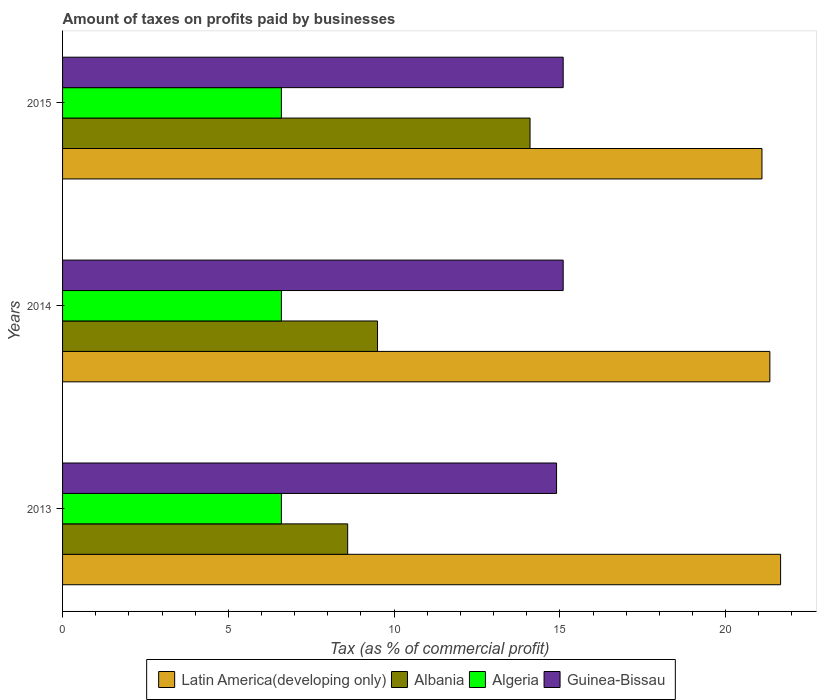How many groups of bars are there?
Offer a very short reply. 3. Are the number of bars per tick equal to the number of legend labels?
Keep it short and to the point. Yes. Are the number of bars on each tick of the Y-axis equal?
Provide a succinct answer. Yes. How many bars are there on the 3rd tick from the bottom?
Provide a succinct answer. 4. What is the label of the 1st group of bars from the top?
Ensure brevity in your answer.  2015. In how many cases, is the number of bars for a given year not equal to the number of legend labels?
Make the answer very short. 0. What is the percentage of taxes paid by businesses in Guinea-Bissau in 2015?
Make the answer very short. 15.1. In which year was the percentage of taxes paid by businesses in Albania maximum?
Your response must be concise. 2015. In which year was the percentage of taxes paid by businesses in Latin America(developing only) minimum?
Offer a terse response. 2015. What is the total percentage of taxes paid by businesses in Latin America(developing only) in the graph?
Provide a succinct answer. 64.09. What is the difference between the percentage of taxes paid by businesses in Algeria in 2014 and the percentage of taxes paid by businesses in Latin America(developing only) in 2015?
Make the answer very short. -14.5. What is the average percentage of taxes paid by businesses in Algeria per year?
Offer a terse response. 6.6. In the year 2014, what is the difference between the percentage of taxes paid by businesses in Latin America(developing only) and percentage of taxes paid by businesses in Albania?
Offer a terse response. 11.83. In how many years, is the percentage of taxes paid by businesses in Algeria greater than 21 %?
Provide a short and direct response. 0. What is the ratio of the percentage of taxes paid by businesses in Algeria in 2013 to that in 2015?
Give a very brief answer. 1. Is the percentage of taxes paid by businesses in Albania in 2013 less than that in 2015?
Your response must be concise. Yes. Is the difference between the percentage of taxes paid by businesses in Latin America(developing only) in 2013 and 2015 greater than the difference between the percentage of taxes paid by businesses in Albania in 2013 and 2015?
Offer a terse response. Yes. What is the difference between the highest and the second highest percentage of taxes paid by businesses in Latin America(developing only)?
Keep it short and to the point. 0.32. What is the difference between the highest and the lowest percentage of taxes paid by businesses in Albania?
Make the answer very short. 5.5. Is it the case that in every year, the sum of the percentage of taxes paid by businesses in Guinea-Bissau and percentage of taxes paid by businesses in Algeria is greater than the sum of percentage of taxes paid by businesses in Albania and percentage of taxes paid by businesses in Latin America(developing only)?
Offer a very short reply. No. What does the 1st bar from the top in 2015 represents?
Offer a terse response. Guinea-Bissau. What does the 1st bar from the bottom in 2015 represents?
Your response must be concise. Latin America(developing only). Are all the bars in the graph horizontal?
Keep it short and to the point. Yes. Does the graph contain any zero values?
Your answer should be very brief. No. Where does the legend appear in the graph?
Your answer should be very brief. Bottom center. How many legend labels are there?
Give a very brief answer. 4. What is the title of the graph?
Your response must be concise. Amount of taxes on profits paid by businesses. What is the label or title of the X-axis?
Provide a short and direct response. Tax (as % of commercial profit). What is the Tax (as % of commercial profit) in Latin America(developing only) in 2013?
Your answer should be compact. 21.66. What is the Tax (as % of commercial profit) of Algeria in 2013?
Provide a short and direct response. 6.6. What is the Tax (as % of commercial profit) in Guinea-Bissau in 2013?
Provide a short and direct response. 14.9. What is the Tax (as % of commercial profit) of Latin America(developing only) in 2014?
Keep it short and to the point. 21.33. What is the Tax (as % of commercial profit) in Albania in 2014?
Your answer should be compact. 9.5. What is the Tax (as % of commercial profit) of Algeria in 2014?
Keep it short and to the point. 6.6. What is the Tax (as % of commercial profit) of Latin America(developing only) in 2015?
Your answer should be compact. 21.1. Across all years, what is the maximum Tax (as % of commercial profit) of Latin America(developing only)?
Provide a succinct answer. 21.66. Across all years, what is the maximum Tax (as % of commercial profit) in Albania?
Give a very brief answer. 14.1. Across all years, what is the maximum Tax (as % of commercial profit) in Guinea-Bissau?
Make the answer very short. 15.1. Across all years, what is the minimum Tax (as % of commercial profit) of Latin America(developing only)?
Give a very brief answer. 21.1. Across all years, what is the minimum Tax (as % of commercial profit) of Algeria?
Your answer should be compact. 6.6. Across all years, what is the minimum Tax (as % of commercial profit) in Guinea-Bissau?
Offer a very short reply. 14.9. What is the total Tax (as % of commercial profit) in Latin America(developing only) in the graph?
Your answer should be very brief. 64.09. What is the total Tax (as % of commercial profit) in Albania in the graph?
Ensure brevity in your answer.  32.2. What is the total Tax (as % of commercial profit) of Algeria in the graph?
Make the answer very short. 19.8. What is the total Tax (as % of commercial profit) in Guinea-Bissau in the graph?
Give a very brief answer. 45.1. What is the difference between the Tax (as % of commercial profit) in Latin America(developing only) in 2013 and that in 2014?
Your answer should be very brief. 0.32. What is the difference between the Tax (as % of commercial profit) of Algeria in 2013 and that in 2014?
Your answer should be compact. 0. What is the difference between the Tax (as % of commercial profit) of Latin America(developing only) in 2013 and that in 2015?
Your answer should be compact. 0.56. What is the difference between the Tax (as % of commercial profit) of Algeria in 2013 and that in 2015?
Offer a terse response. 0. What is the difference between the Tax (as % of commercial profit) in Latin America(developing only) in 2014 and that in 2015?
Offer a very short reply. 0.24. What is the difference between the Tax (as % of commercial profit) in Albania in 2014 and that in 2015?
Your answer should be compact. -4.6. What is the difference between the Tax (as % of commercial profit) in Latin America(developing only) in 2013 and the Tax (as % of commercial profit) in Albania in 2014?
Provide a succinct answer. 12.16. What is the difference between the Tax (as % of commercial profit) of Latin America(developing only) in 2013 and the Tax (as % of commercial profit) of Algeria in 2014?
Give a very brief answer. 15.06. What is the difference between the Tax (as % of commercial profit) of Latin America(developing only) in 2013 and the Tax (as % of commercial profit) of Guinea-Bissau in 2014?
Ensure brevity in your answer.  6.56. What is the difference between the Tax (as % of commercial profit) in Albania in 2013 and the Tax (as % of commercial profit) in Guinea-Bissau in 2014?
Offer a terse response. -6.5. What is the difference between the Tax (as % of commercial profit) in Algeria in 2013 and the Tax (as % of commercial profit) in Guinea-Bissau in 2014?
Make the answer very short. -8.5. What is the difference between the Tax (as % of commercial profit) of Latin America(developing only) in 2013 and the Tax (as % of commercial profit) of Albania in 2015?
Your response must be concise. 7.56. What is the difference between the Tax (as % of commercial profit) in Latin America(developing only) in 2013 and the Tax (as % of commercial profit) in Algeria in 2015?
Offer a very short reply. 15.06. What is the difference between the Tax (as % of commercial profit) of Latin America(developing only) in 2013 and the Tax (as % of commercial profit) of Guinea-Bissau in 2015?
Provide a succinct answer. 6.56. What is the difference between the Tax (as % of commercial profit) of Algeria in 2013 and the Tax (as % of commercial profit) of Guinea-Bissau in 2015?
Offer a terse response. -8.5. What is the difference between the Tax (as % of commercial profit) in Latin America(developing only) in 2014 and the Tax (as % of commercial profit) in Albania in 2015?
Your answer should be compact. 7.23. What is the difference between the Tax (as % of commercial profit) of Latin America(developing only) in 2014 and the Tax (as % of commercial profit) of Algeria in 2015?
Offer a terse response. 14.73. What is the difference between the Tax (as % of commercial profit) of Latin America(developing only) in 2014 and the Tax (as % of commercial profit) of Guinea-Bissau in 2015?
Provide a succinct answer. 6.23. What is the difference between the Tax (as % of commercial profit) in Albania in 2014 and the Tax (as % of commercial profit) in Algeria in 2015?
Ensure brevity in your answer.  2.9. What is the difference between the Tax (as % of commercial profit) of Albania in 2014 and the Tax (as % of commercial profit) of Guinea-Bissau in 2015?
Your answer should be very brief. -5.6. What is the difference between the Tax (as % of commercial profit) of Algeria in 2014 and the Tax (as % of commercial profit) of Guinea-Bissau in 2015?
Give a very brief answer. -8.5. What is the average Tax (as % of commercial profit) of Latin America(developing only) per year?
Give a very brief answer. 21.36. What is the average Tax (as % of commercial profit) of Albania per year?
Provide a short and direct response. 10.73. What is the average Tax (as % of commercial profit) of Guinea-Bissau per year?
Offer a terse response. 15.03. In the year 2013, what is the difference between the Tax (as % of commercial profit) in Latin America(developing only) and Tax (as % of commercial profit) in Albania?
Offer a very short reply. 13.06. In the year 2013, what is the difference between the Tax (as % of commercial profit) in Latin America(developing only) and Tax (as % of commercial profit) in Algeria?
Your answer should be compact. 15.06. In the year 2013, what is the difference between the Tax (as % of commercial profit) in Latin America(developing only) and Tax (as % of commercial profit) in Guinea-Bissau?
Your answer should be very brief. 6.76. In the year 2013, what is the difference between the Tax (as % of commercial profit) in Albania and Tax (as % of commercial profit) in Algeria?
Provide a short and direct response. 2. In the year 2013, what is the difference between the Tax (as % of commercial profit) in Algeria and Tax (as % of commercial profit) in Guinea-Bissau?
Your answer should be very brief. -8.3. In the year 2014, what is the difference between the Tax (as % of commercial profit) in Latin America(developing only) and Tax (as % of commercial profit) in Albania?
Keep it short and to the point. 11.83. In the year 2014, what is the difference between the Tax (as % of commercial profit) in Latin America(developing only) and Tax (as % of commercial profit) in Algeria?
Keep it short and to the point. 14.73. In the year 2014, what is the difference between the Tax (as % of commercial profit) of Latin America(developing only) and Tax (as % of commercial profit) of Guinea-Bissau?
Your answer should be very brief. 6.23. In the year 2014, what is the difference between the Tax (as % of commercial profit) of Albania and Tax (as % of commercial profit) of Algeria?
Ensure brevity in your answer.  2.9. In the year 2015, what is the difference between the Tax (as % of commercial profit) of Latin America(developing only) and Tax (as % of commercial profit) of Albania?
Provide a succinct answer. 7. In the year 2015, what is the difference between the Tax (as % of commercial profit) in Latin America(developing only) and Tax (as % of commercial profit) in Algeria?
Your response must be concise. 14.5. In the year 2015, what is the difference between the Tax (as % of commercial profit) in Latin America(developing only) and Tax (as % of commercial profit) in Guinea-Bissau?
Your response must be concise. 6. In the year 2015, what is the difference between the Tax (as % of commercial profit) in Albania and Tax (as % of commercial profit) in Guinea-Bissau?
Your answer should be very brief. -1. In the year 2015, what is the difference between the Tax (as % of commercial profit) of Algeria and Tax (as % of commercial profit) of Guinea-Bissau?
Offer a very short reply. -8.5. What is the ratio of the Tax (as % of commercial profit) in Latin America(developing only) in 2013 to that in 2014?
Your answer should be compact. 1.02. What is the ratio of the Tax (as % of commercial profit) of Albania in 2013 to that in 2014?
Your answer should be very brief. 0.91. What is the ratio of the Tax (as % of commercial profit) of Algeria in 2013 to that in 2014?
Provide a short and direct response. 1. What is the ratio of the Tax (as % of commercial profit) of Guinea-Bissau in 2013 to that in 2014?
Your answer should be very brief. 0.99. What is the ratio of the Tax (as % of commercial profit) in Latin America(developing only) in 2013 to that in 2015?
Your answer should be very brief. 1.03. What is the ratio of the Tax (as % of commercial profit) in Albania in 2013 to that in 2015?
Give a very brief answer. 0.61. What is the ratio of the Tax (as % of commercial profit) in Algeria in 2013 to that in 2015?
Offer a terse response. 1. What is the ratio of the Tax (as % of commercial profit) of Latin America(developing only) in 2014 to that in 2015?
Your answer should be compact. 1.01. What is the ratio of the Tax (as % of commercial profit) in Albania in 2014 to that in 2015?
Provide a succinct answer. 0.67. What is the ratio of the Tax (as % of commercial profit) of Guinea-Bissau in 2014 to that in 2015?
Provide a short and direct response. 1. What is the difference between the highest and the second highest Tax (as % of commercial profit) in Latin America(developing only)?
Offer a terse response. 0.32. What is the difference between the highest and the lowest Tax (as % of commercial profit) in Latin America(developing only)?
Keep it short and to the point. 0.56. What is the difference between the highest and the lowest Tax (as % of commercial profit) of Algeria?
Your response must be concise. 0. 